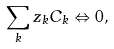<formula> <loc_0><loc_0><loc_500><loc_500>\sum _ { k } z _ { k } C _ { k } \Leftrightarrow 0 ,</formula> 